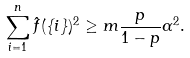<formula> <loc_0><loc_0><loc_500><loc_500>\sum _ { i = 1 } ^ { n } \hat { f } ( \{ i \} ) ^ { 2 } \geq m \frac { p } { 1 - p } \alpha ^ { 2 } .</formula> 